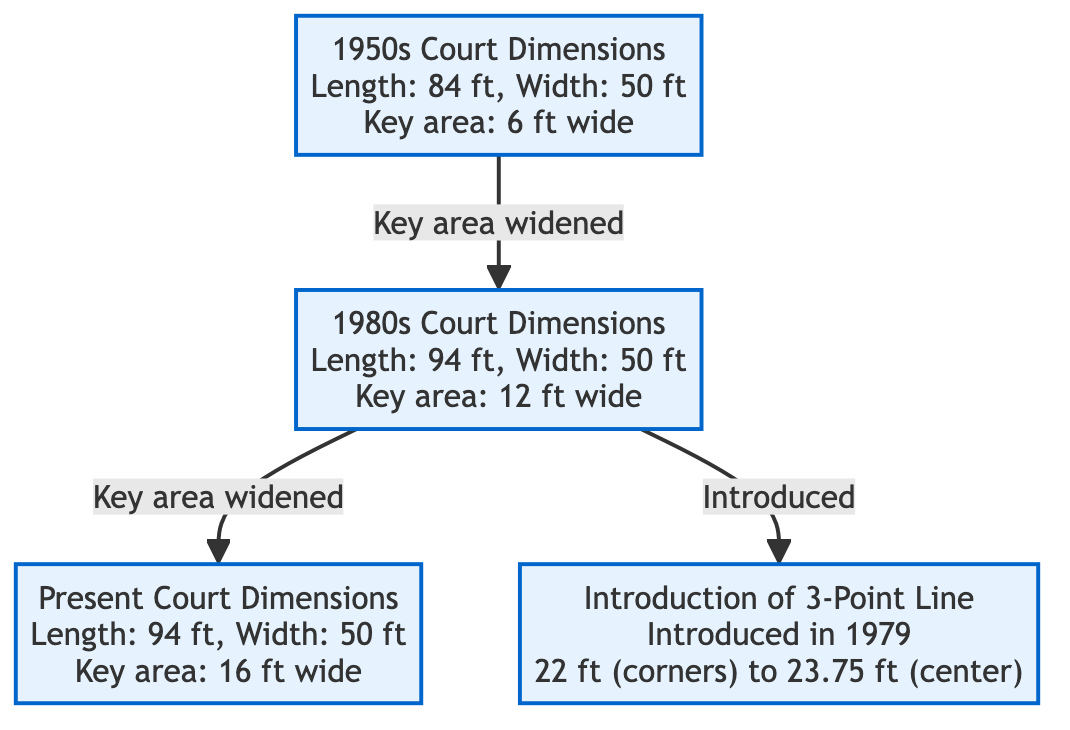What were the court dimensions in the 1950s? The diagram specifies the court dimensions for the 1950s as Length: 84 ft and Width: 50 ft. I look directly at the node labeled "1950s Court Dimensions" to extract this information.
Answer: Length: 84 ft, Width: 50 ft What is the key area width in the present day? In the node labeled "Present Court Dimensions," the key area width is noted as 16 ft wide. I identify this detail directly within that node.
Answer: 16 ft wide How much wider is the key area in the present court compared to the 1950s? The width of the key area in the present is stated as 16 ft while in the 1950s, it was 6 ft. To find the difference, I calculate 16 ft - 6 ft, which equals 10 ft.
Answer: 10 ft In what year was the three-point line introduced? The diagram specifically indicates that the three-point line was introduced in 1979 within the node labeled "Introduction of 3-Point Line." I extract this year directly from that information.
Answer: 1979 What is the length of the court in the 1980s? The "1980s Court Dimensions" node specifies that the length of the court is 94 ft. I simply refer to that node to find this detail.
Answer: 94 ft What is the relationship between the 1980s court dimensions and the introduction of the three-point line? According to the diagram, the 1980s node connects to the "Introduction of 3-Point Line," indicating it was introduced during that era as shown by the directed edge. This connection shows that the three-point line was a significant change introduced in the sport's evolution during that time.
Answer: Introduced How wide was the key area in the 1980s? The width of the key area for the 1980s is given as 12 ft in the "1980s Court Dimensions" node. I identify this detail directly from that node.
Answer: 12 ft wide What are the present court dimensions in total? The current court dimensions noted in the diagram are Length: 94 ft and Width: 50 ft. To find the total dimensions, I combine both measurements, indicating they remain the same as 94 ft by 50 ft.
Answer: Length: 94 ft, Width: 50 ft What type of diagram is this? The structure and notation suggest this is a "Textbook Diagram," which illustrates information in a flowchart format. My understanding of the diagram class indicates it fit this description.
Answer: Textbook Diagram 